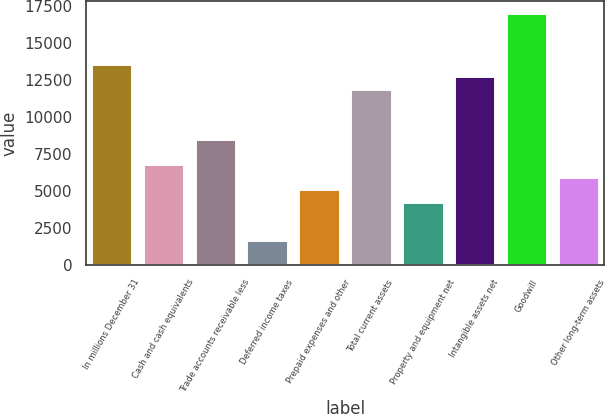Convert chart. <chart><loc_0><loc_0><loc_500><loc_500><bar_chart><fcel>In millions December 31<fcel>Cash and cash equivalents<fcel>Trade accounts receivable less<fcel>Deferred income taxes<fcel>Prepaid expenses and other<fcel>Total current assets<fcel>Property and equipment net<fcel>Intangible assets net<fcel>Goodwill<fcel>Other long-term assets<nl><fcel>13594<fcel>6798<fcel>8497<fcel>1701<fcel>5099<fcel>11895<fcel>4249.5<fcel>12744.5<fcel>16992<fcel>5948.5<nl></chart> 